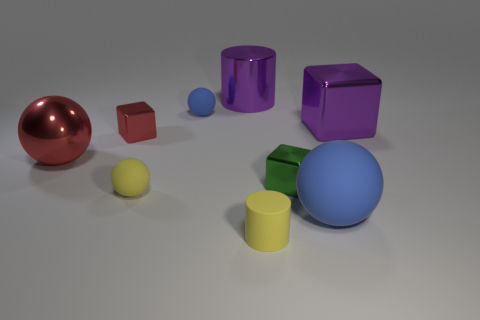Subtract all large blocks. How many blocks are left? 2 Subtract all red blocks. How many blocks are left? 2 Add 3 tiny gray matte objects. How many tiny gray matte objects exist? 3 Add 1 green cubes. How many objects exist? 10 Subtract 1 purple cubes. How many objects are left? 8 Subtract all cubes. How many objects are left? 6 Subtract 1 balls. How many balls are left? 3 Subtract all gray cylinders. Subtract all yellow spheres. How many cylinders are left? 2 Subtract all cyan cubes. How many cyan balls are left? 0 Subtract all small yellow rubber objects. Subtract all big red objects. How many objects are left? 6 